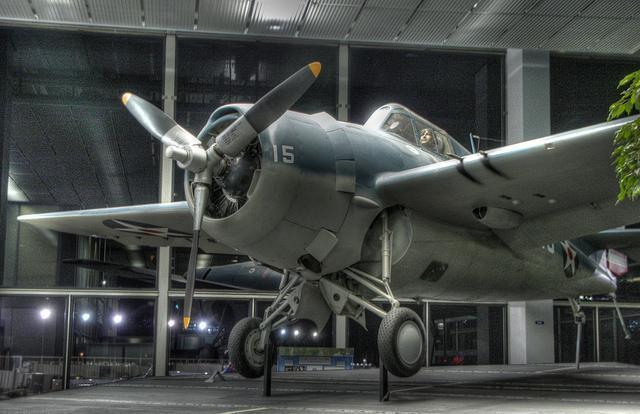How many blades on the propeller?
Give a very brief answer. 3. How many non-red buses are in the street?
Give a very brief answer. 0. 